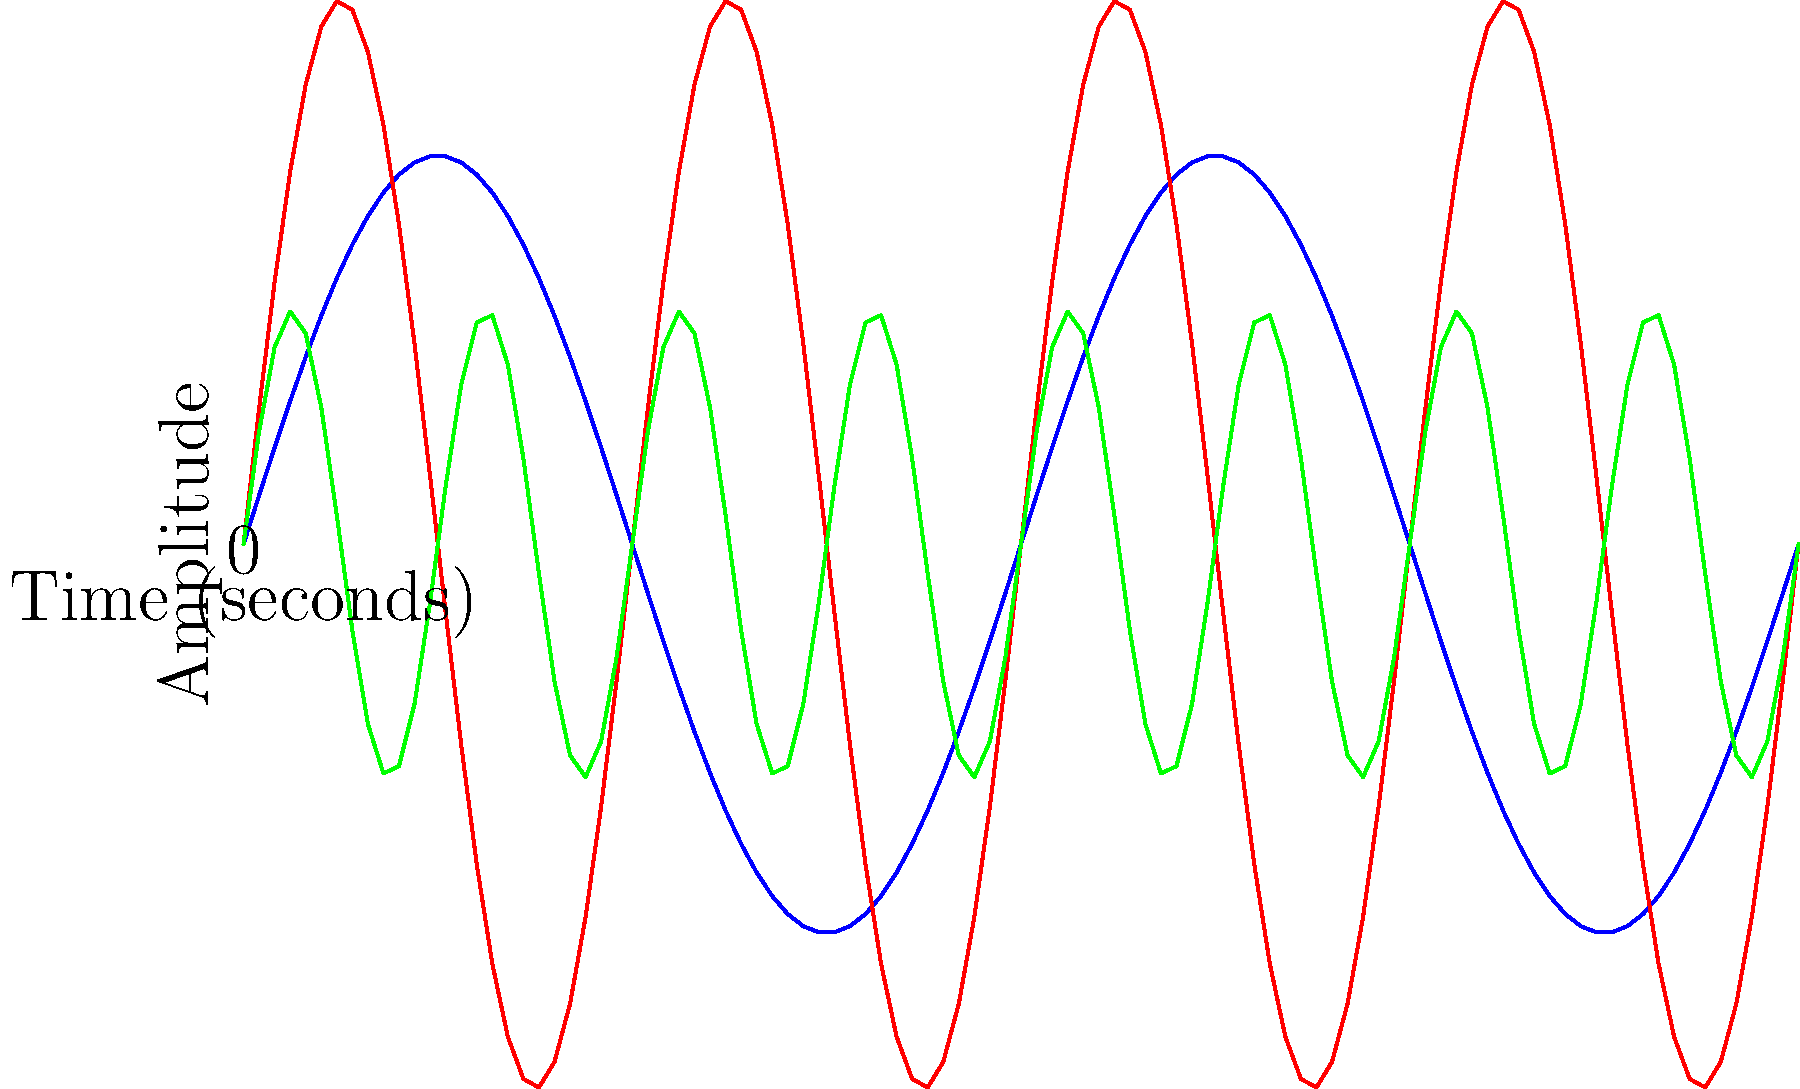As a dance student, you're learning to match your movements to different musical beat patterns. The graph shows three waveforms representing different dance rhythms: slow (blue), medium (red), and fast (green). Which waveform would be most suitable for a quick, energetic dance move sequence? To determine which waveform is most suitable for a quick, energetic dance move sequence, let's analyze each waveform:

1. Blue waveform (Slow):
   - Has the lowest frequency (completes 1 cycle in 2 seconds)
   - Represents slower, more gradual movements

2. Red waveform (Medium):
   - Has a medium frequency (completes 2 cycles in 2 seconds)
   - Represents moderate-paced movements

3. Green waveform (Fast):
   - Has the highest frequency (completes 4 cycles in 2 seconds)
   - Represents quick, rapid movements

For a quick, energetic dance move sequence, we want the waveform with the highest frequency, as it corresponds to faster beats and more rapid movements. This allows dancers to perform more steps and actions within a given time frame, creating a sense of energy and intensity in the choreography.

Therefore, the green waveform, which has the highest frequency and completes the most cycles in the given time period, is the most suitable for a quick, energetic dance move sequence.
Answer: Green waveform (Fast) 